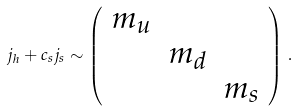Convert formula to latex. <formula><loc_0><loc_0><loc_500><loc_500>j _ { h } + c _ { s } j _ { s } \sim \left ( \begin{array} { c c c } m _ { u } & & \\ & m _ { d } & \\ & & m _ { s } \end{array} \right ) \, .</formula> 